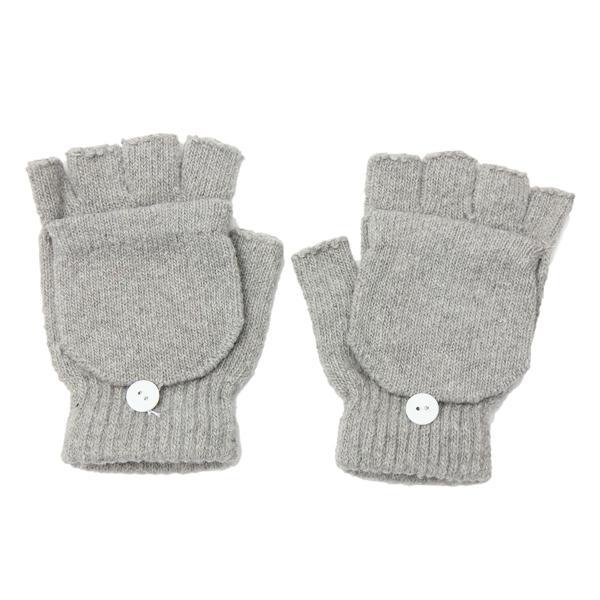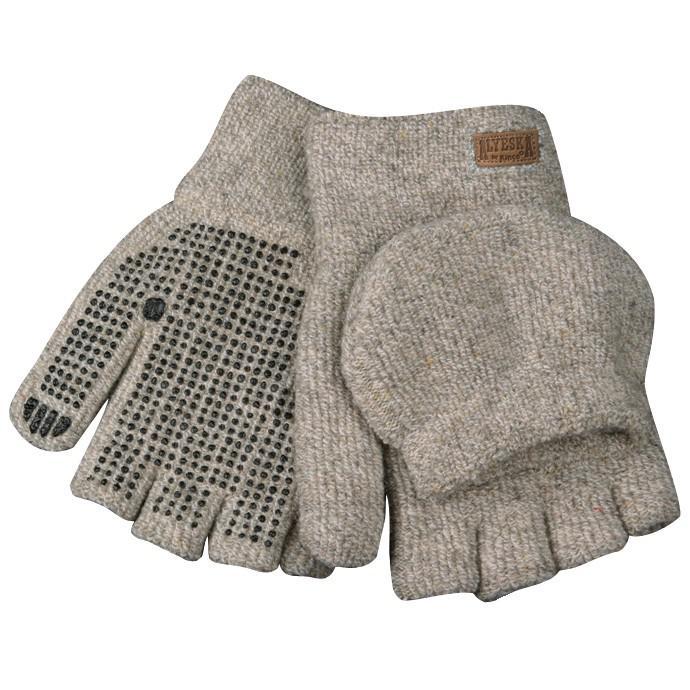The first image is the image on the left, the second image is the image on the right. Assess this claim about the two images: "Two mittens are shown covered.". Correct or not? Answer yes or no. No. The first image is the image on the left, the second image is the image on the right. Evaluate the accuracy of this statement regarding the images: "The gloves are made of a knitted material.". Is it true? Answer yes or no. Yes. 